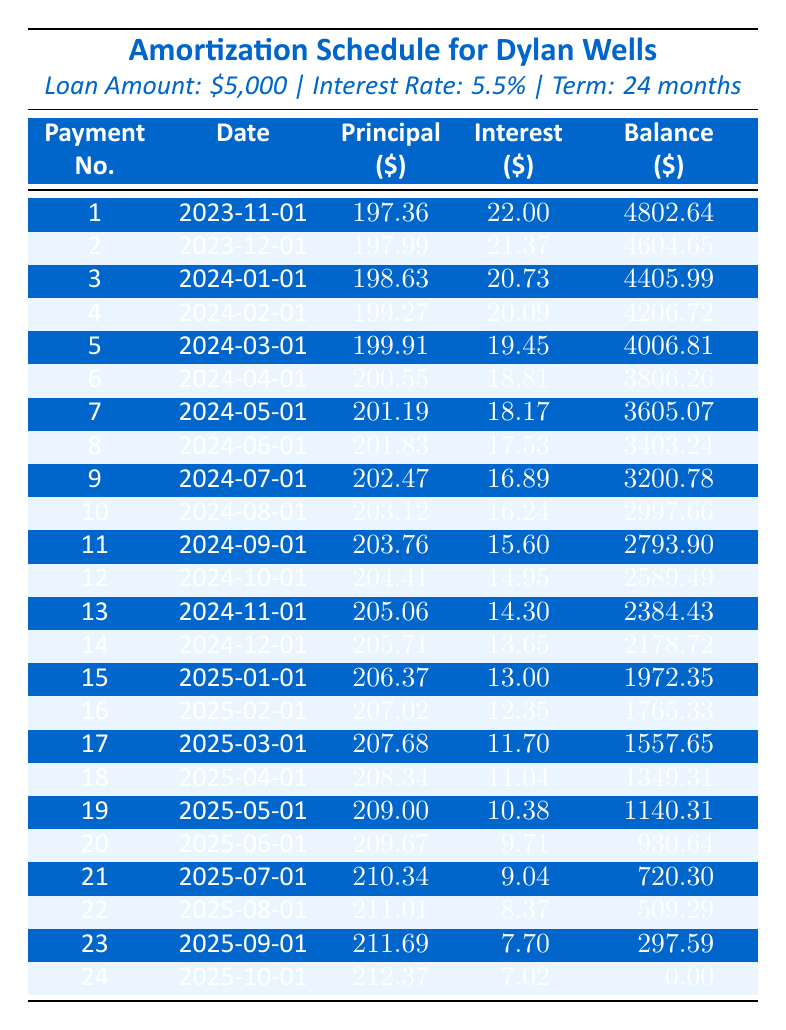What is the total monthly payment for this loan? The loan's monthly payment amount is directly referenced in the loan details, which shows the monthly payment as $219.36.
Answer: 219.36 How much principal is paid in the first payment? In the first payment information, the principal payment is provided as $197.36.
Answer: 197.36 How much does the remaining balance decrease after the 5th payment? The remaining balance after the 4th payment is $4206.72, and after the 5th payment, it is $4006.81. The decrease is calculated as $4206.72 - $4006.81 = $199.91.
Answer: 199.91 What is the average interest payment over the entire loan term? To find the average interest payment, we sum up all monthly interest payments listed and divide by the number of payments (24). The total interest payment is calculated as follows: 22.00 + 21.37 + 20.73 + 20.09 + 19.45 + 18.81 + 18.17 + 17.53 + 16.89 + 16.24 + 15.60 + 14.95 + 14.30 + 13.65 + 13.00 + 12.35 + 11.70 + 11.04 + 10.38 + 9.71 + 9.04 + 8.37 + 7.70 + 7.02 = 255.76, so the average is 255.76 / 24 ≈ 10.66.
Answer: 10.66 Is the interest payment decreasing every month? By examining the interest payments on the table, we can see that each month's interest payment is less than the previous month's, indicating a consistent decrease.
Answer: Yes What is the total principal paid by the end of the loan? The principal paid can be calculated by summing all principal payments throughout the loan term. Summing the provided principal payments yields a total of $2499.76 (or calculating it as $5000 - $0.00).
Answer: 2499.76 How much is the total interest paid by the end of the loan? The total interest can be calculated by summing the interest payments: 22.00 + 21.37 + 20.73 + 20.09 + ... + 7.02 totals to 224.76. Adding this to the total principal gives an overall payment amount of $5000, hence, total interest = total payment - total principal = $279.76.
Answer: 279.76 What is the remaining balance after the 12th payment? Checking the amortization schedule, we can directly see that the remaining balance after the 12th payment is listed as $2589.49.
Answer: 2589.49 On which payment date is the highest principal payment made? By scanning through the principal payments, the highest payment is found at the 24th payment, which is $212.37.
Answer: 212.37 